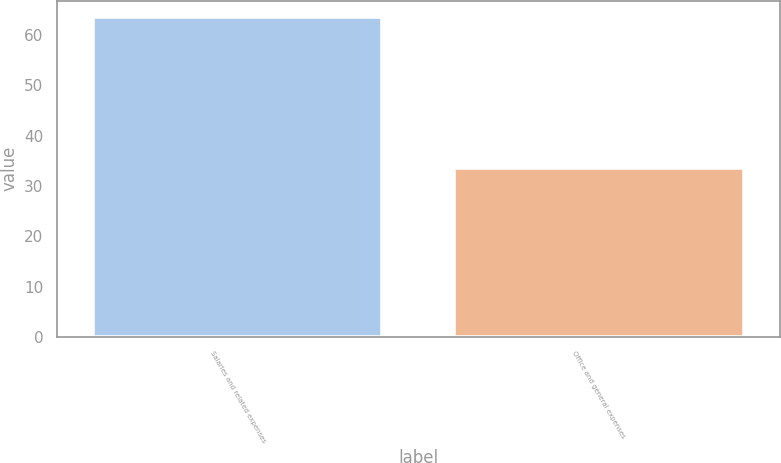<chart> <loc_0><loc_0><loc_500><loc_500><bar_chart><fcel>Salaries and related expenses<fcel>Office and general expenses<nl><fcel>63.7<fcel>33.6<nl></chart> 